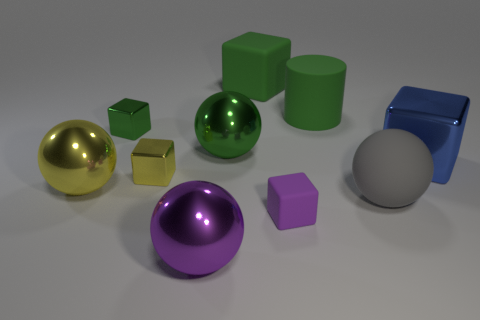Subtract all large blue blocks. How many blocks are left? 4 Subtract all blue blocks. How many blocks are left? 4 Subtract all cyan blocks. Subtract all green cylinders. How many blocks are left? 5 Subtract all spheres. How many objects are left? 6 Add 1 large gray spheres. How many large gray spheres exist? 2 Subtract 0 brown spheres. How many objects are left? 10 Subtract all shiny things. Subtract all gray spheres. How many objects are left? 3 Add 6 big cubes. How many big cubes are left? 8 